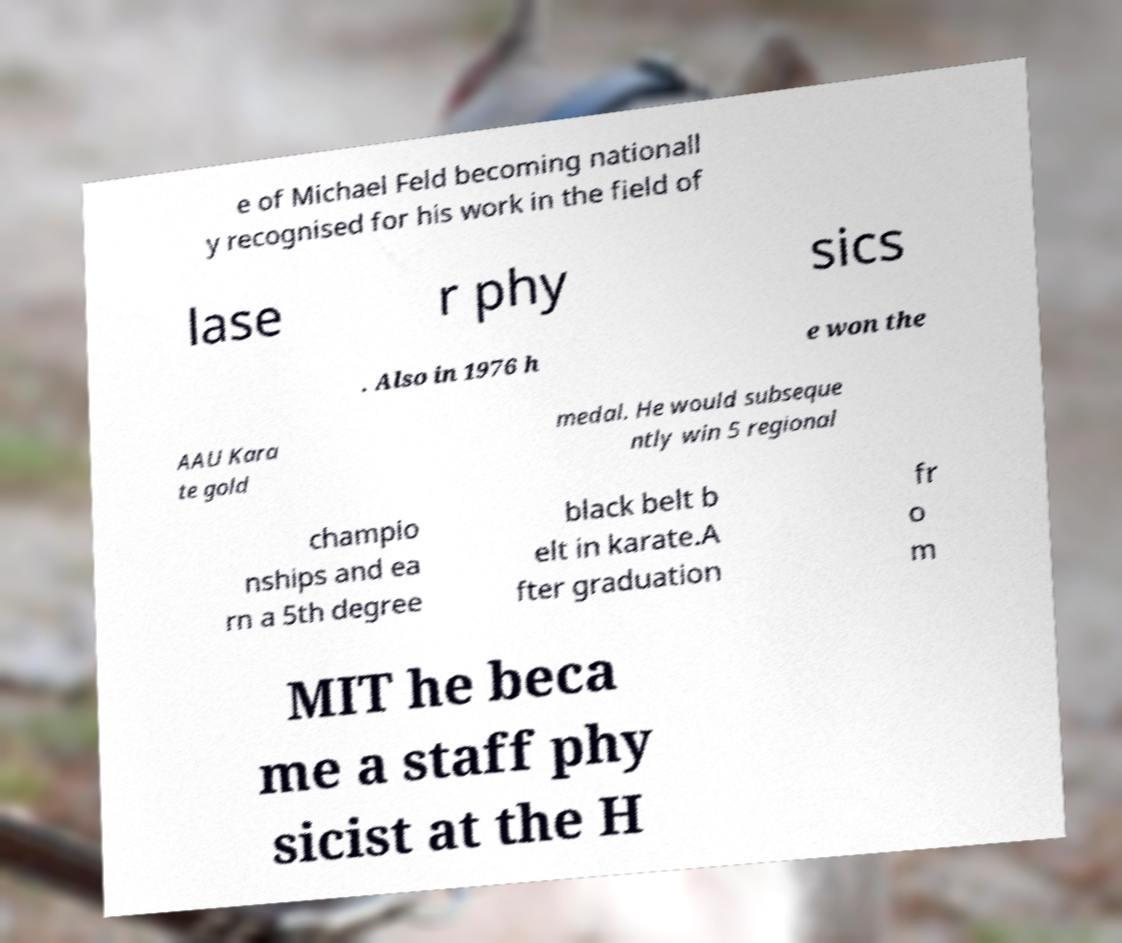Can you read and provide the text displayed in the image?This photo seems to have some interesting text. Can you extract and type it out for me? e of Michael Feld becoming nationall y recognised for his work in the field of lase r phy sics . Also in 1976 h e won the AAU Kara te gold medal. He would subseque ntly win 5 regional champio nships and ea rn a 5th degree black belt b elt in karate.A fter graduation fr o m MIT he beca me a staff phy sicist at the H 